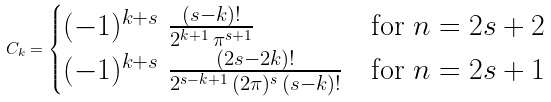Convert formula to latex. <formula><loc_0><loc_0><loc_500><loc_500>C _ { k } = \begin{cases} ( - 1 ) ^ { k + s } \ \frac { ( s - k ) ! } { 2 ^ { k + 1 } \, \pi ^ { s + 1 } } & \text {for $n=2s+2$} \\ ( - 1 ) ^ { k + s } \ \frac { ( 2 s - 2 k ) ! } { 2 ^ { s - k + 1 } \, ( 2 \pi ) ^ { s } \, ( s - k ) ! } & \text {for $n=2s+1$} \end{cases}</formula> 